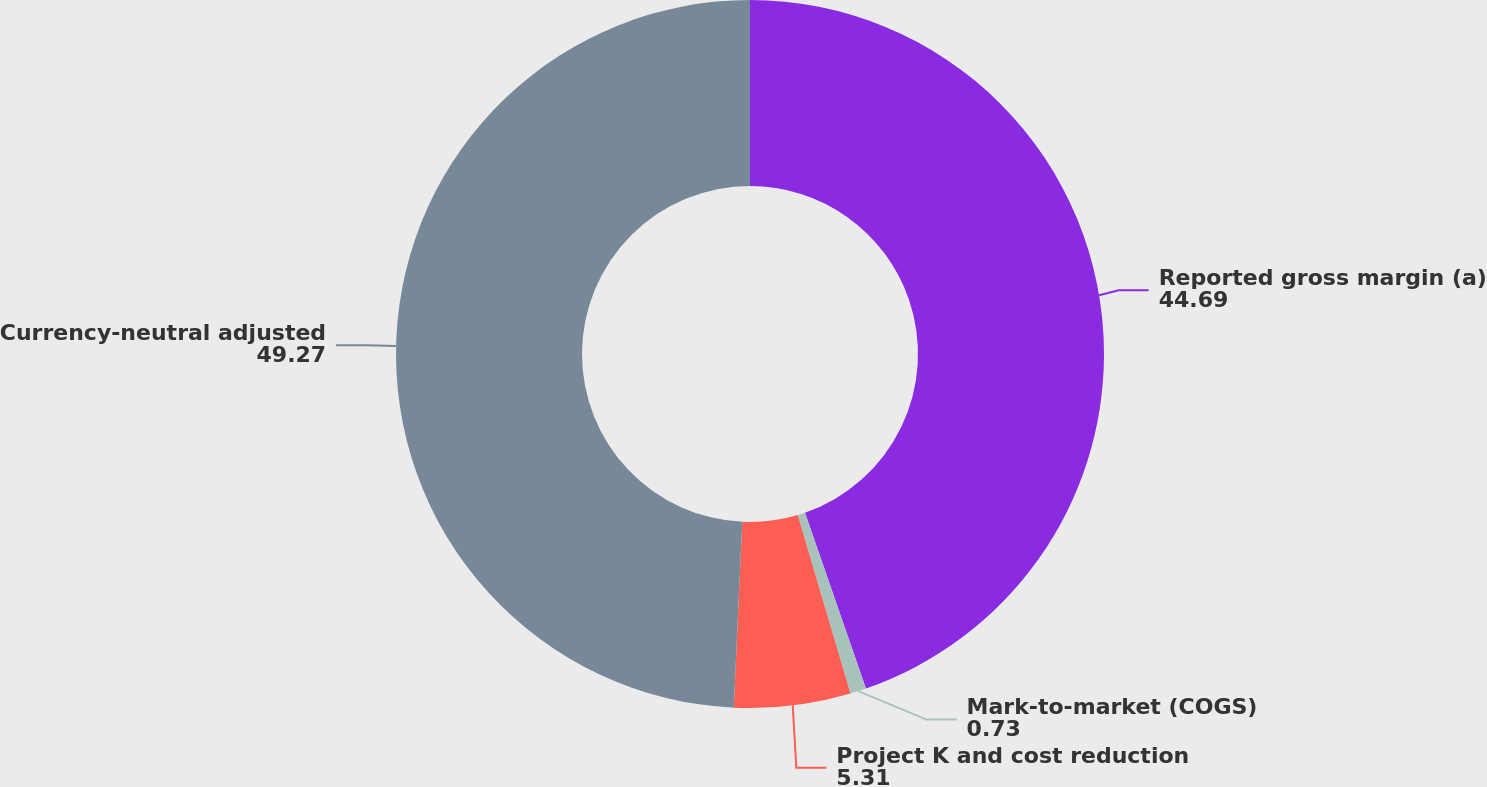Convert chart to OTSL. <chart><loc_0><loc_0><loc_500><loc_500><pie_chart><fcel>Reported gross margin (a)<fcel>Mark-to-market (COGS)<fcel>Project K and cost reduction<fcel>Currency-neutral adjusted<nl><fcel>44.69%<fcel>0.73%<fcel>5.31%<fcel>49.27%<nl></chart> 